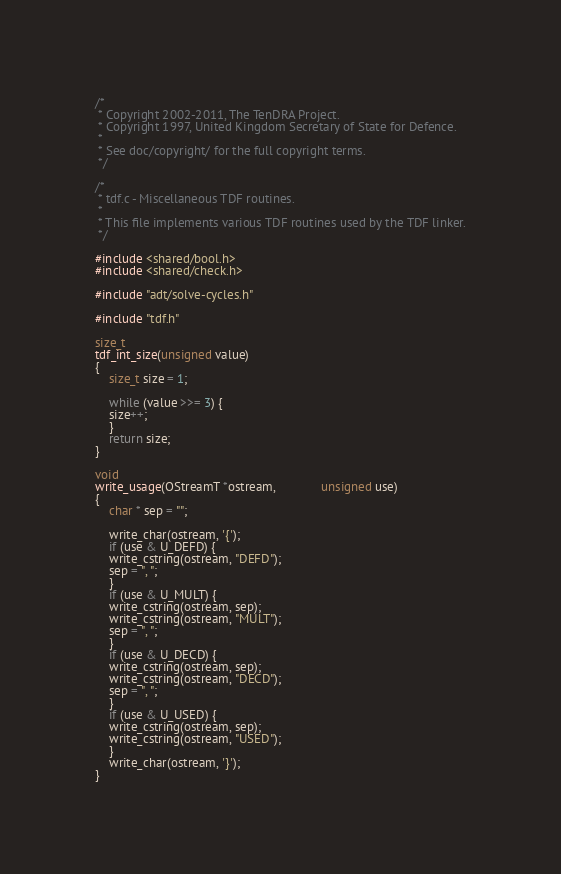Convert code to text. <code><loc_0><loc_0><loc_500><loc_500><_C_>/*
 * Copyright 2002-2011, The TenDRA Project.
 * Copyright 1997, United Kingdom Secretary of State for Defence.
 *
 * See doc/copyright/ for the full copyright terms.
 */

/*
 * tdf.c - Miscellaneous TDF routines.
 *
 * This file implements various TDF routines used by the TDF linker.
 */

#include <shared/bool.h>
#include <shared/check.h>

#include "adt/solve-cycles.h"

#include "tdf.h"

size_t
tdf_int_size(unsigned value)
{
    size_t size = 1;

    while (value >>= 3) {
	size++;
    }
    return size;
}

void
write_usage(OStreamT *ostream,		     unsigned use)
{
    char * sep = "";

    write_char(ostream, '{');
    if (use & U_DEFD) {
	write_cstring(ostream, "DEFD");
	sep = ", ";
    }
    if (use & U_MULT) {
	write_cstring(ostream, sep);
	write_cstring(ostream, "MULT");
	sep = ", ";
    }
    if (use & U_DECD) {
	write_cstring(ostream, sep);
	write_cstring(ostream, "DECD");
	sep = ", ";
    }
    if (use & U_USED) {
	write_cstring(ostream, sep);
	write_cstring(ostream, "USED");
    }
    write_char(ostream, '}');
}
</code> 